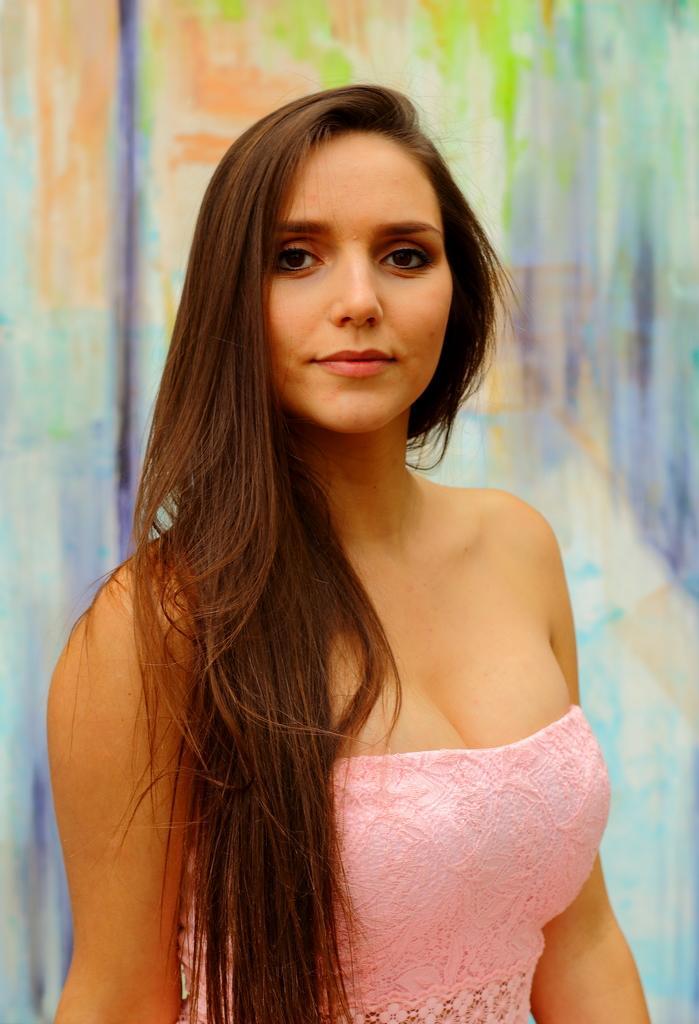Could you give a brief overview of what you see in this image? In the middle of the image there is a lady with pink dress is stunning. Behind her there is a color full background. 